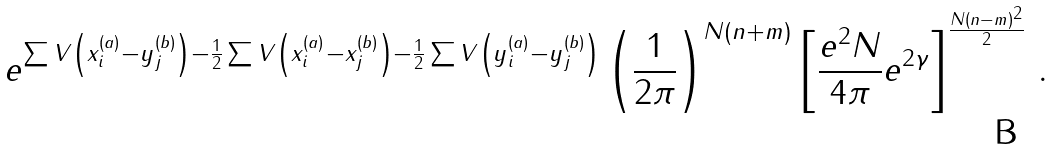<formula> <loc_0><loc_0><loc_500><loc_500>e ^ { \sum V \left ( x _ { i } ^ { ( a ) } - y _ { j } ^ { ( b ) } \right ) - \frac { 1 } { 2 } \sum V \left ( x _ { i } ^ { ( a ) } - x _ { j } ^ { ( b ) } \right ) - \frac { 1 } { 2 } \sum V \left ( y _ { i } ^ { ( a ) } - y _ { j } ^ { ( b ) } \right ) } \left ( \frac { 1 } { 2 \pi } \right ) ^ { N ( n + m ) } \left [ \frac { e ^ { 2 } N } { 4 \pi } e ^ { 2 \gamma } \right ] ^ { \frac { N ( n - m ) ^ { 2 } } { 2 } } \, .</formula> 